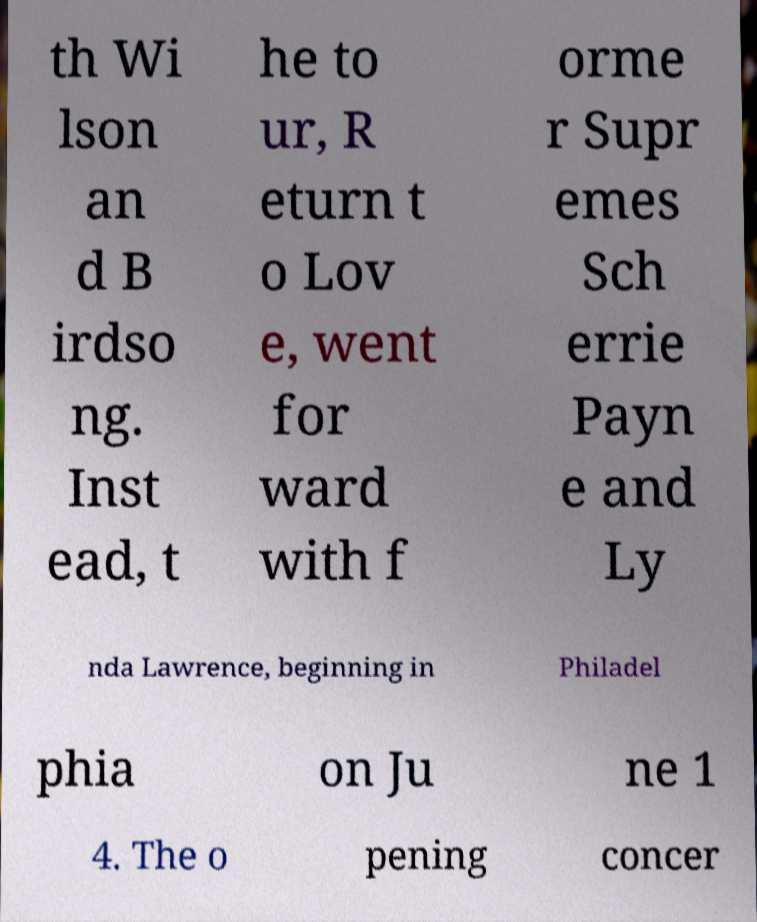I need the written content from this picture converted into text. Can you do that? th Wi lson an d B irdso ng. Inst ead, t he to ur, R eturn t o Lov e, went for ward with f orme r Supr emes Sch errie Payn e and Ly nda Lawrence, beginning in Philadel phia on Ju ne 1 4. The o pening concer 